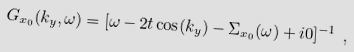Convert formula to latex. <formula><loc_0><loc_0><loc_500><loc_500>G _ { x _ { 0 } } ( k _ { y } , \omega ) = [ \omega - 2 t \cos ( k _ { y } ) - \Sigma _ { x _ { 0 } } ( \omega ) + i 0 ] ^ { - 1 } \ ,</formula> 